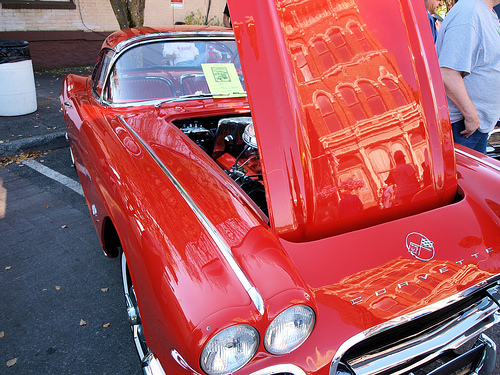<image>
Is there a hood behind the car? No. The hood is not behind the car. From this viewpoint, the hood appears to be positioned elsewhere in the scene. 